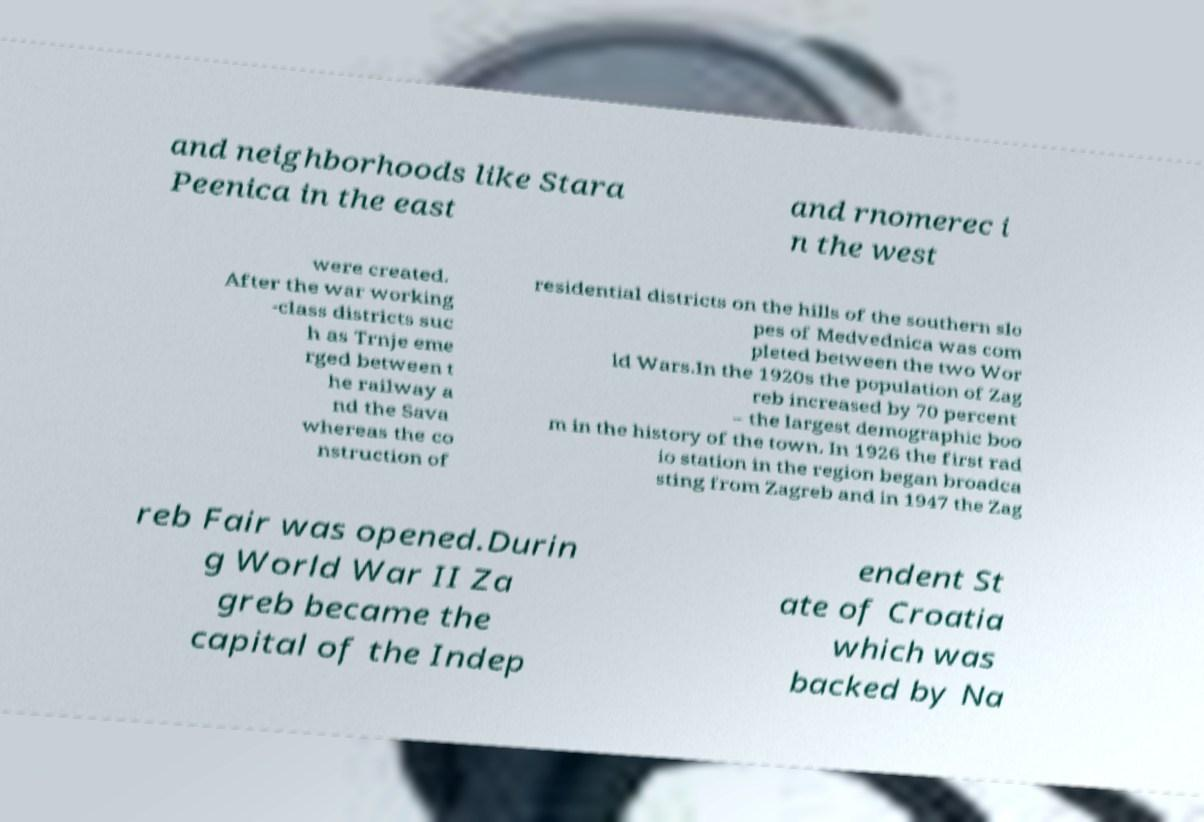Please identify and transcribe the text found in this image. and neighborhoods like Stara Peenica in the east and rnomerec i n the west were created. After the war working -class districts suc h as Trnje eme rged between t he railway a nd the Sava whereas the co nstruction of residential districts on the hills of the southern slo pes of Medvednica was com pleted between the two Wor ld Wars.In the 1920s the population of Zag reb increased by 70 percent – the largest demographic boo m in the history of the town. In 1926 the first rad io station in the region began broadca sting from Zagreb and in 1947 the Zag reb Fair was opened.Durin g World War II Za greb became the capital of the Indep endent St ate of Croatia which was backed by Na 